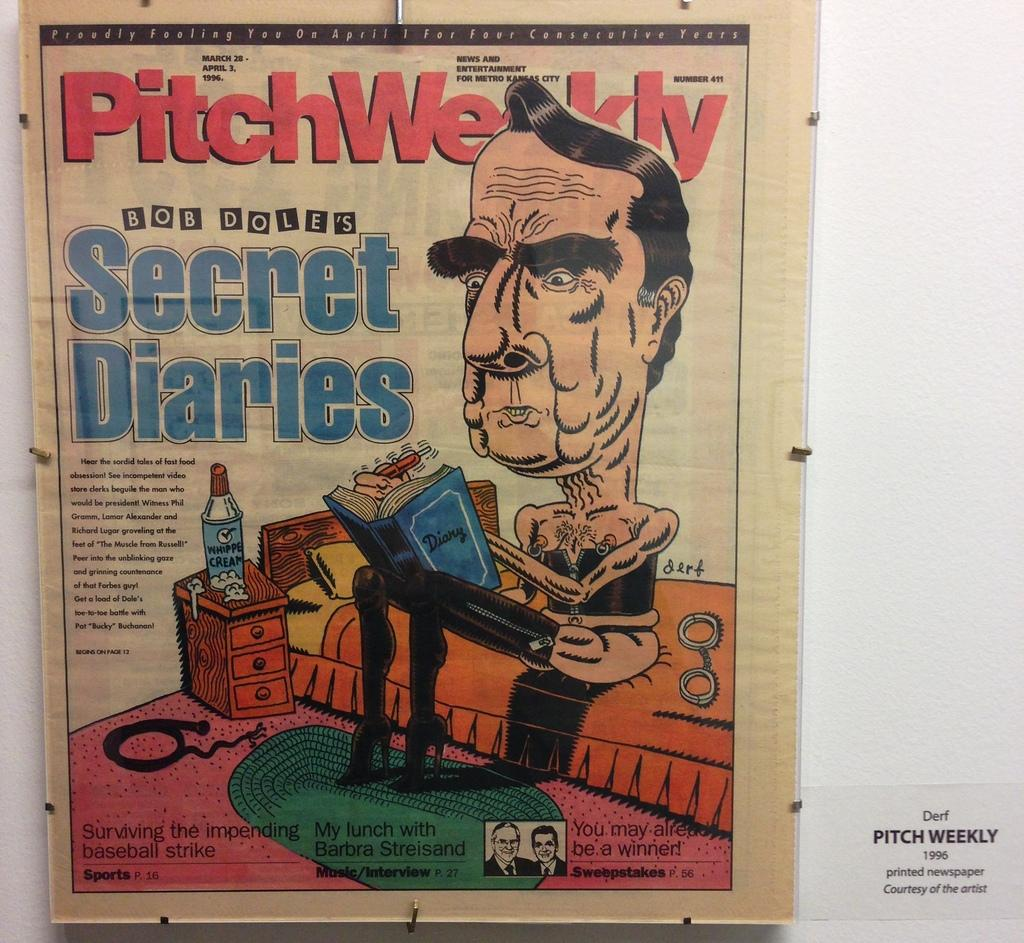<image>
Give a short and clear explanation of the subsequent image. A printed newspaper from 1996 from Pitch Weekly. 